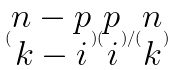Convert formula to latex. <formula><loc_0><loc_0><loc_500><loc_500>( \begin{matrix} n - p \\ k - i \end{matrix} ) ( \begin{matrix} p \\ i \end{matrix} ) / ( \begin{matrix} n \\ k \end{matrix} )</formula> 